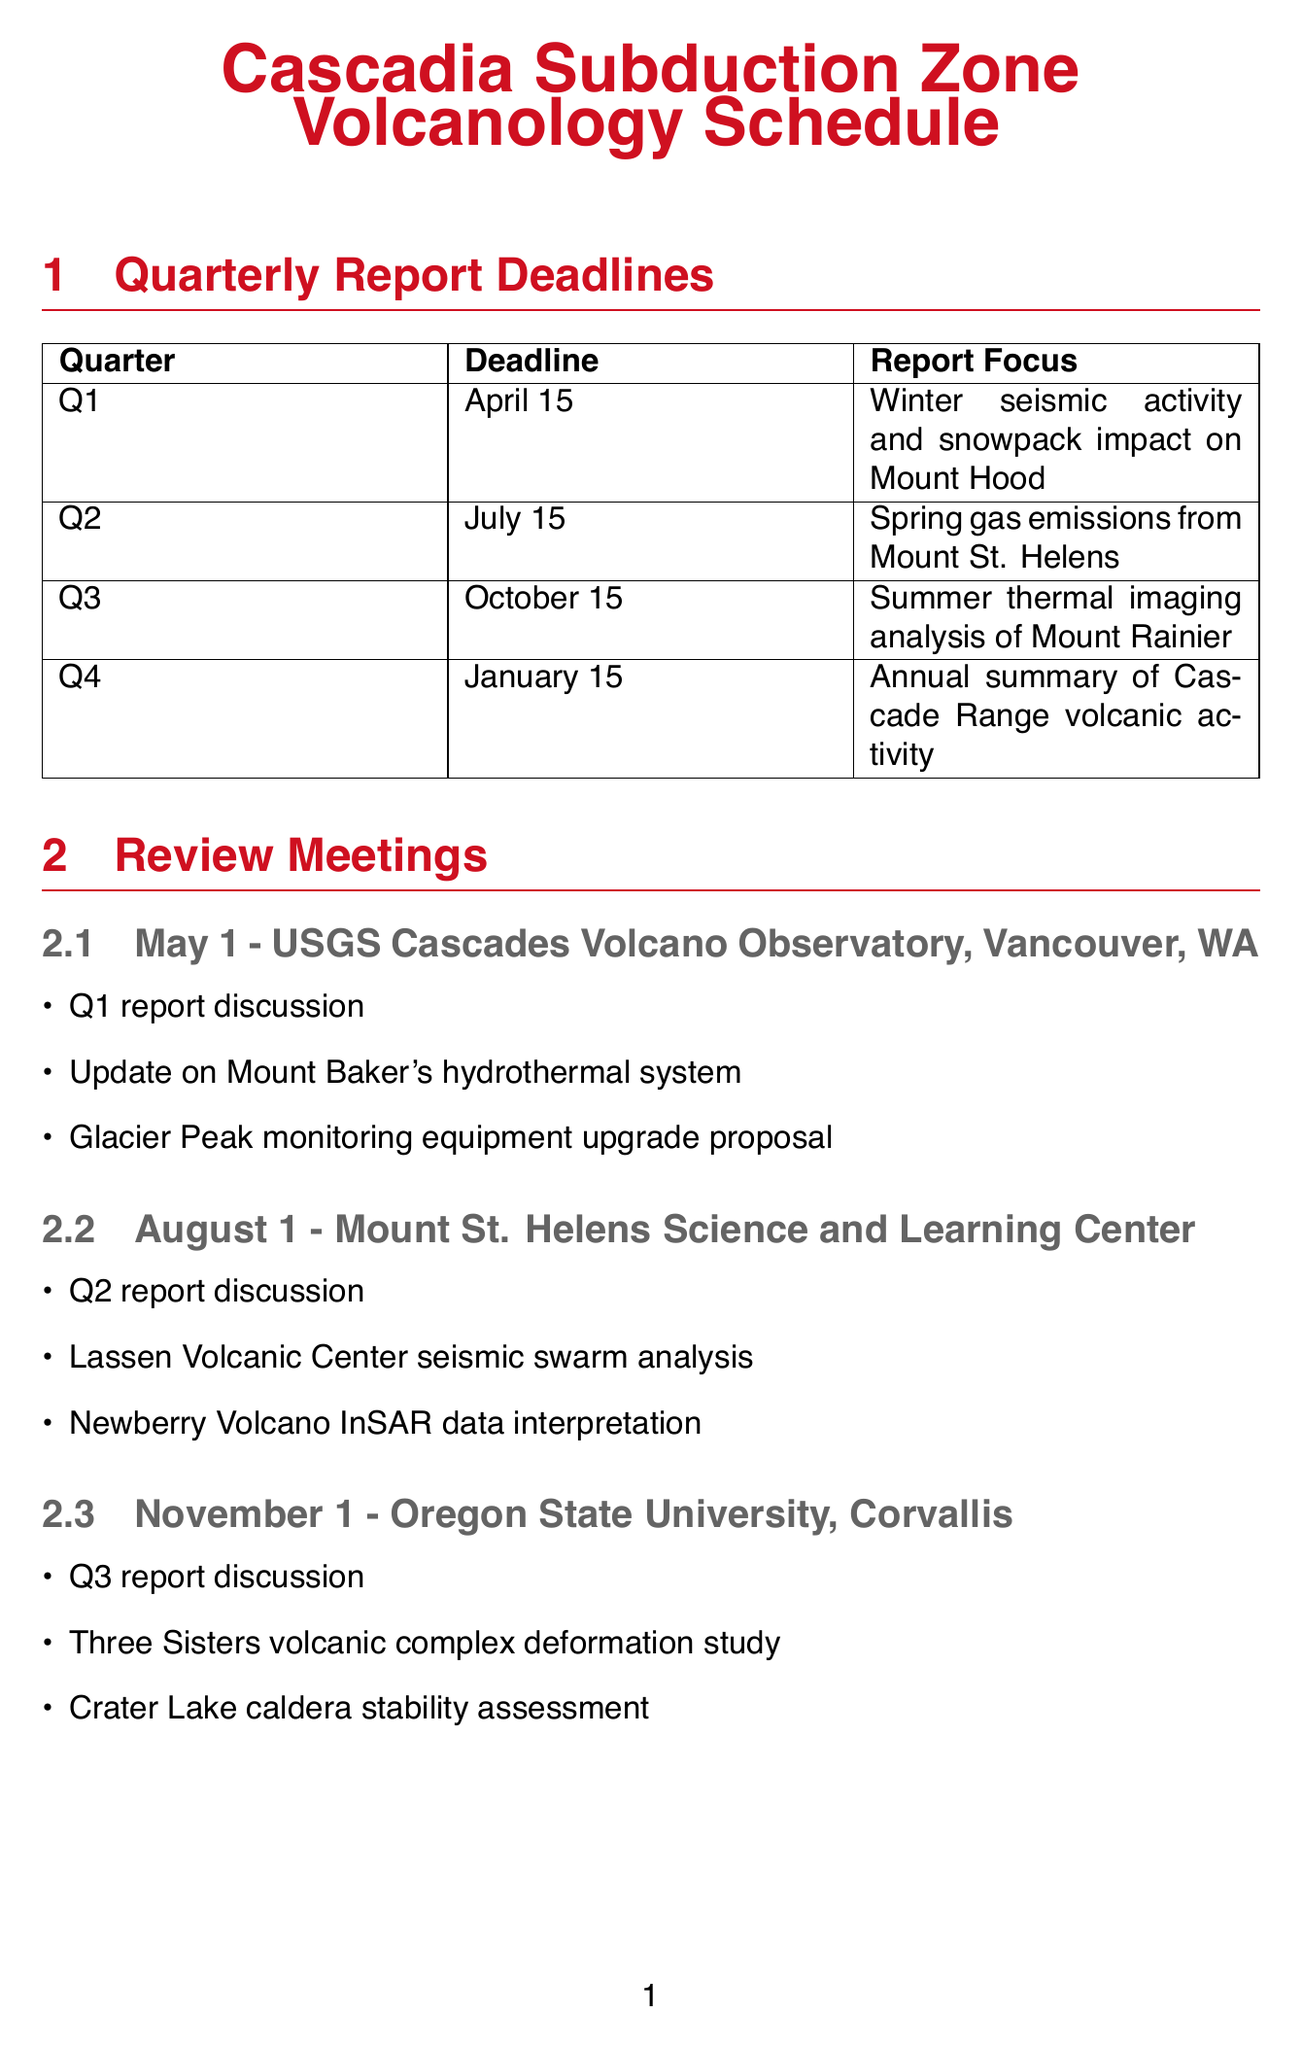What is the deadline for Q1 reports? The deadline for Q1 reports is specified in the document as April 15.
Answer: April 15 What is the focus of the Q3 report? The focus of the Q3 report is detailed in the document as Summer thermal imaging analysis of Mount Rainier.
Answer: Summer thermal imaging analysis of Mount Rainier When is the review meeting for the Q2 report scheduled? The schedule indicates the review meeting for the Q2 report is on August 1.
Answer: August 1 Where will the Q4 report discussion take place? The document specifies the Q4 report discussion will occur at the University of Washington, Seattle.
Answer: University of Washington, Seattle What event takes place on May 15? The event scheduled for May 15 is described in the document as the Cascades Volcano Observatory Open House.
Answer: Cascades Volcano Observatory Open House How many review meetings are there in total? The total number of review meetings is calculated from the list in the document, which includes four meetings.
Answer: 4 Which location hosts the review meeting after Q3? The document states the review meeting after Q3 will be hosted at Oregon State University, Corvallis.
Answer: Oregon State University, Corvallis What is the main agenda for the review meeting on November 1? The agenda includes multiple topics, with the main one being the Q3 report discussion.
Answer: Q3 report discussion What is the date of the AGU Fall Meeting? According to the document, the AGU Fall Meeting is scheduled for December 11-15.
Answer: December 11-15 